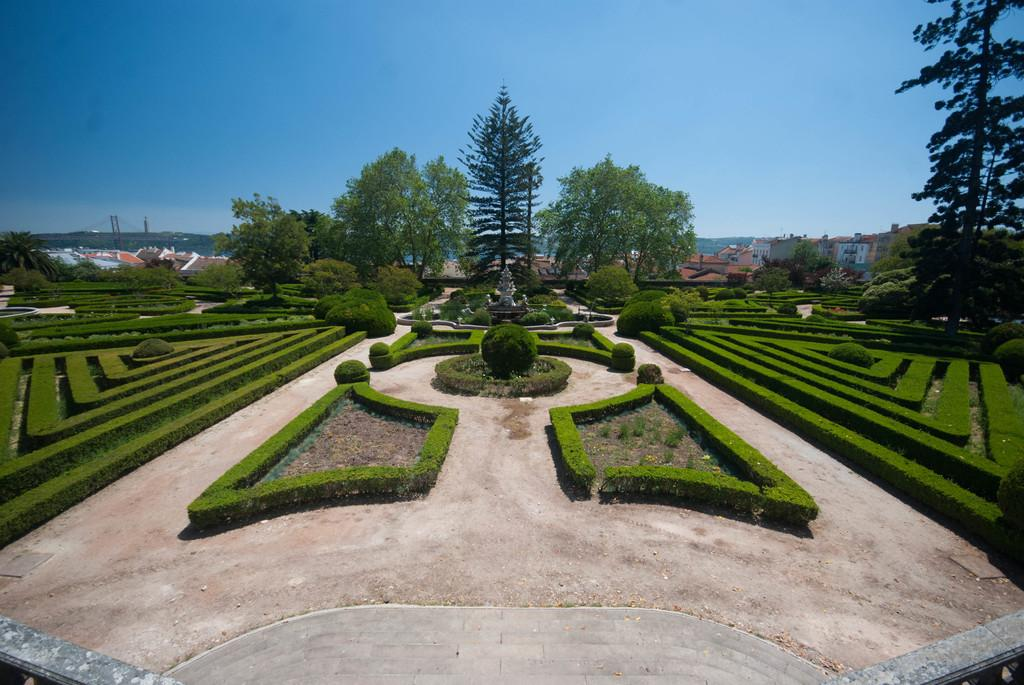What type of outdoor space is depicted in the image? The image contains a garden. What types of plants can be seen in the garden? There are bushes and trees in the garden. What structures are visible in the background of the garden? There are houses visible at the back side of the garden. What is visible at the top of the image? The sky is visible at the top of the image. What type of art can be seen hanging from the trees in the garden? There is no art visible hanging from the trees in the image. What is the smell of the garden in the image? The image is a visual representation and does not convey smells, so it is not possible to determine the smell of the garden from the image. 